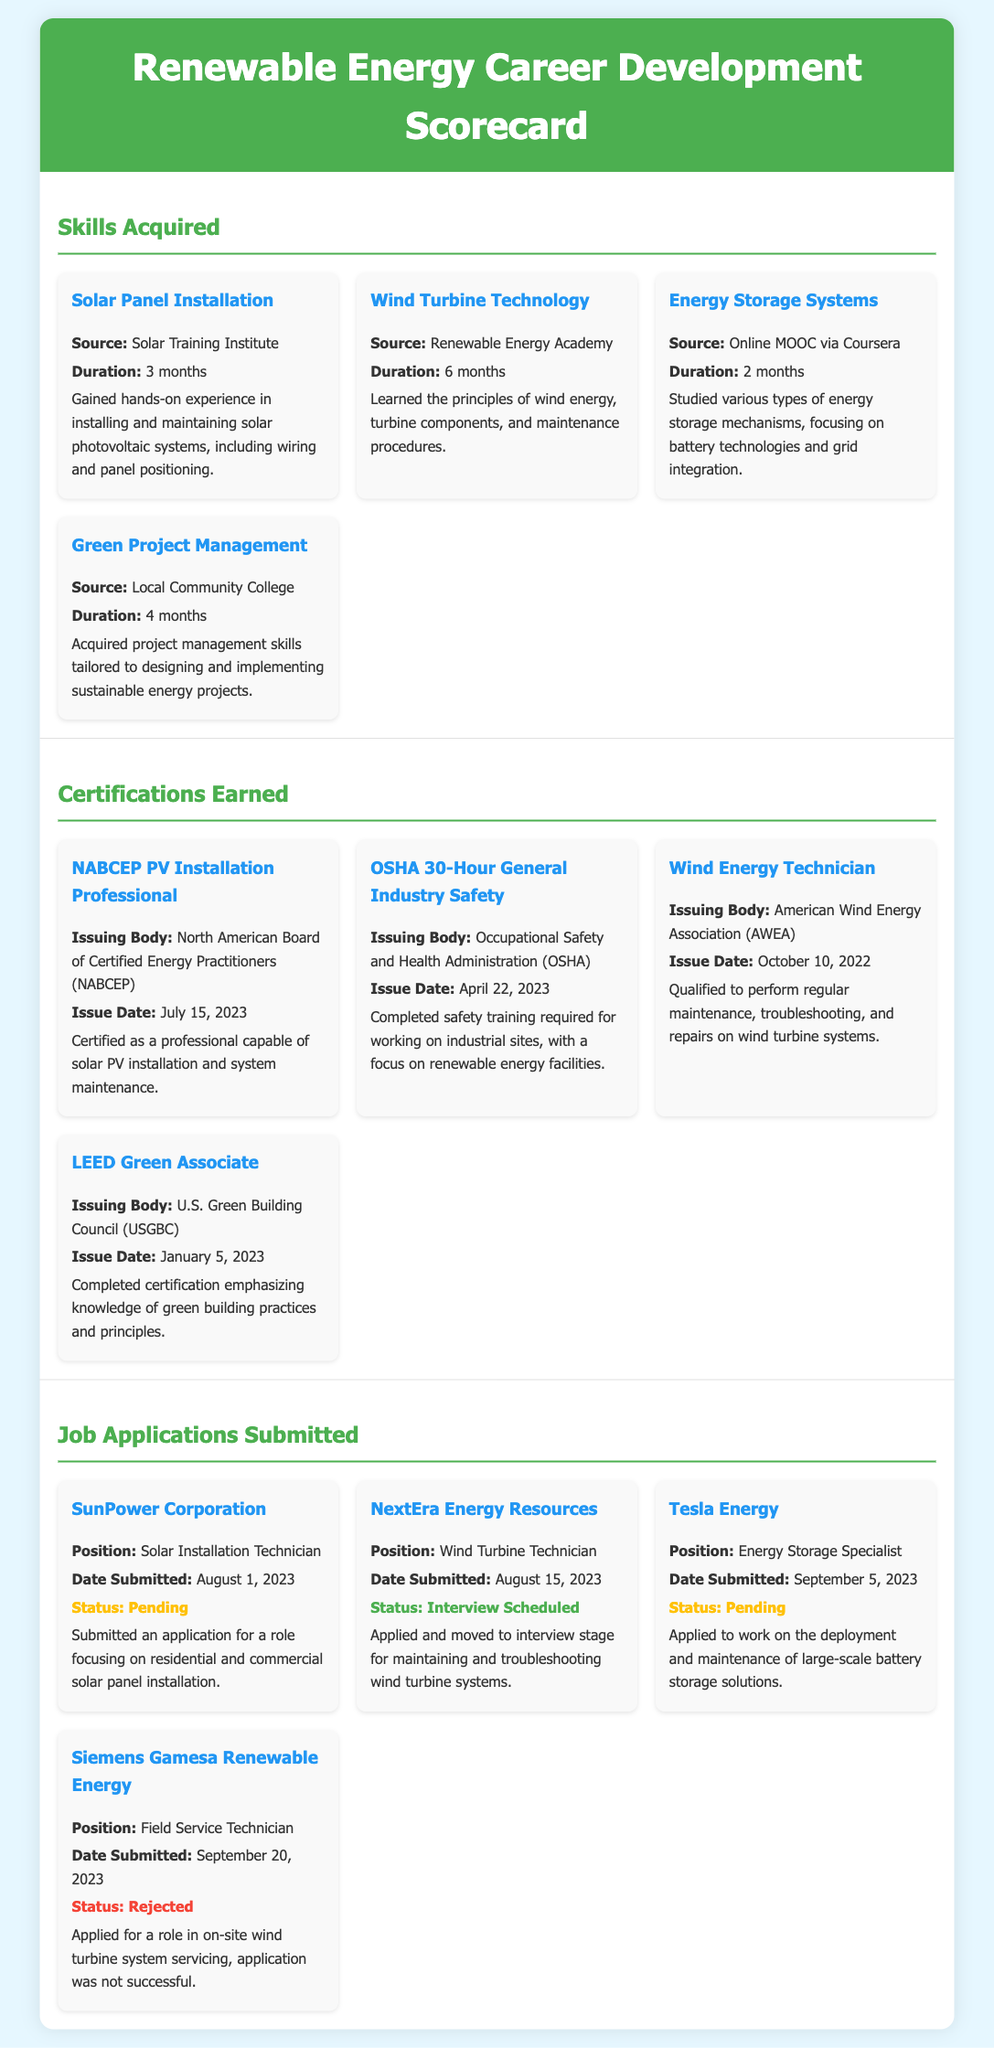What is the duration of the Solar Panel Installation course? The duration of the Solar Panel Installation course is specified in the document as 3 months.
Answer: 3 months Who issued the NABCEP PV Installation Professional certification? The issuing body for the NABCEP PV Installation Professional certification is mentioned as the North American Board of Certified Energy Practitioners (NABCEP).
Answer: North American Board of Certified Energy Practitioners (NABCEP) What is the status of the application for the Siemens Gamesa Renewable Energy position? The document states that the application for the Siemens Gamesa Renewable Energy position was not successful, indicating a rejection status.
Answer: Rejected How many skills were acquired according to the scorecard? The scorecard lists four skills acquired: Solar Panel Installation, Wind Turbine Technology, Energy Storage Systems, and Green Project Management.
Answer: 4 What is the issue date of the OSHA 30-Hour General Industry Safety certification? The issue date of the OSHA 30-Hour General Industry Safety certification is found in the document as April 22, 2023.
Answer: April 22, 2023 Which company is the job application for the Energy Storage Specialist position submitted to? The application for the Energy Storage Specialist position is specifically submitted to Tesla Energy as indicated in the document.
Answer: Tesla Energy What type of training does the OSHA certification pertain to? The certification training relates to general industry safety, specifically for working on industrial sites with a focus on renewable energy facilities.
Answer: General industry safety How many job applications were submitted? The scorecard details four job applications that have been submitted.
Answer: 4 What is the position applied for at NextEra Energy Resources? The position applied for at NextEra Energy Resources, as listed in the document, is for a Wind Turbine Technician.
Answer: Wind Turbine Technician 